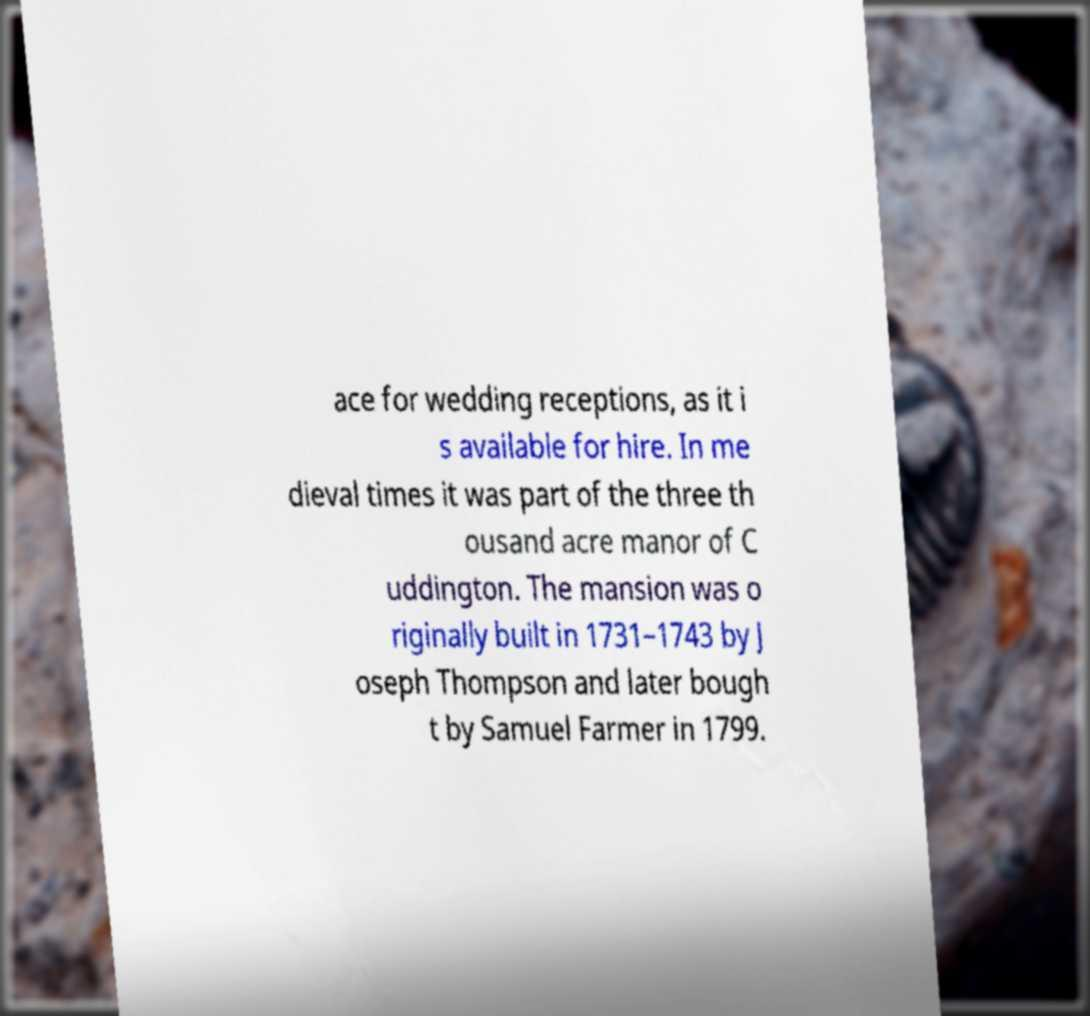Could you extract and type out the text from this image? ace for wedding receptions, as it i s available for hire. In me dieval times it was part of the three th ousand acre manor of C uddington. The mansion was o riginally built in 1731–1743 by J oseph Thompson and later bough t by Samuel Farmer in 1799. 